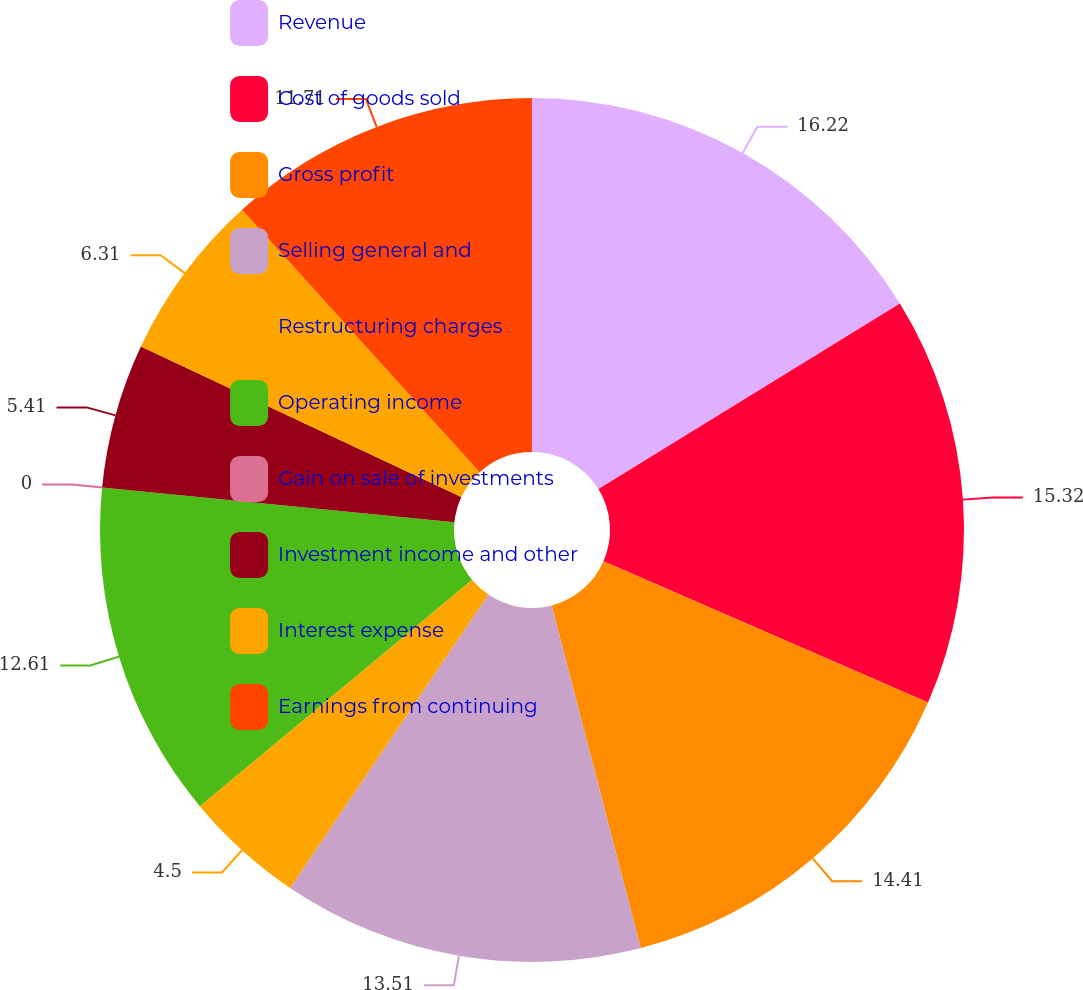Convert chart to OTSL. <chart><loc_0><loc_0><loc_500><loc_500><pie_chart><fcel>Revenue<fcel>Cost of goods sold<fcel>Gross profit<fcel>Selling general and<fcel>Restructuring charges<fcel>Operating income<fcel>Gain on sale of investments<fcel>Investment income and other<fcel>Interest expense<fcel>Earnings from continuing<nl><fcel>16.22%<fcel>15.32%<fcel>14.41%<fcel>13.51%<fcel>4.5%<fcel>12.61%<fcel>0.0%<fcel>5.41%<fcel>6.31%<fcel>11.71%<nl></chart> 